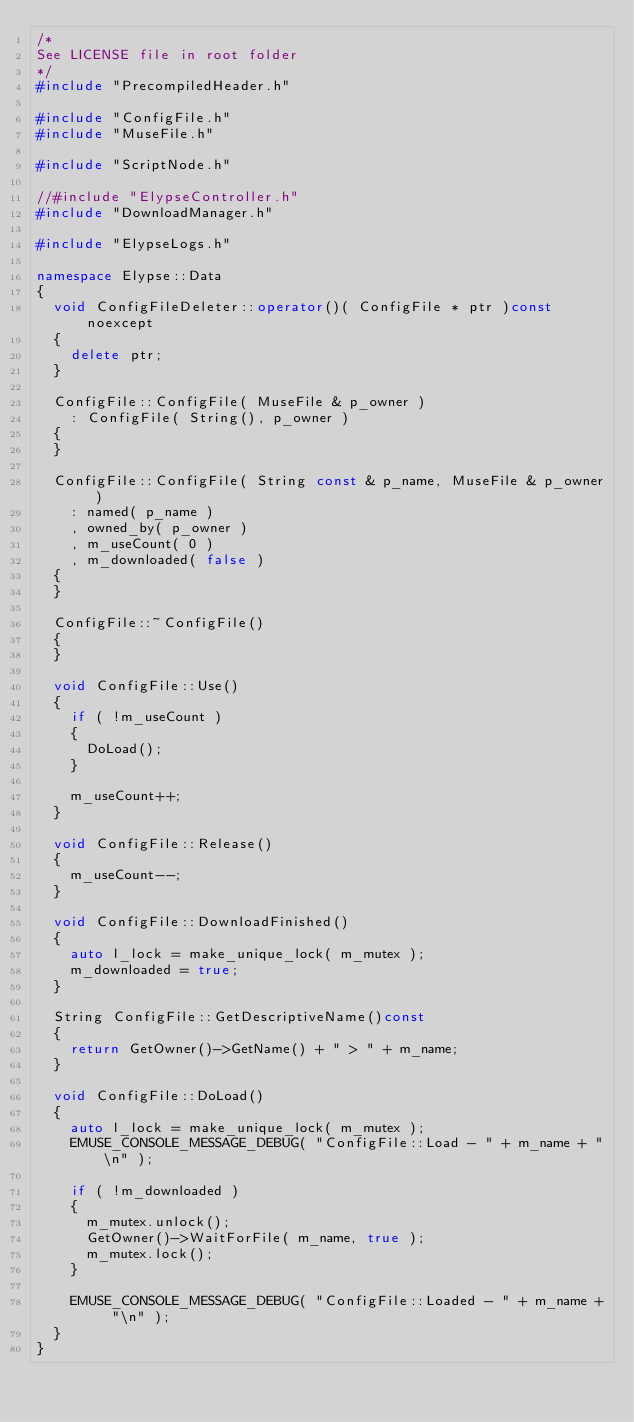<code> <loc_0><loc_0><loc_500><loc_500><_C++_>/*
See LICENSE file in root folder
*/
#include "PrecompiledHeader.h"

#include "ConfigFile.h"
#include "MuseFile.h"

#include "ScriptNode.h"

//#include "ElypseController.h"
#include "DownloadManager.h"

#include "ElypseLogs.h"

namespace Elypse::Data
{
	void ConfigFileDeleter::operator()( ConfigFile * ptr )const noexcept
	{
		delete ptr;
	}

	ConfigFile::ConfigFile( MuseFile & p_owner )
		: ConfigFile( String(), p_owner )
	{
	}

	ConfigFile::ConfigFile( String const & p_name, MuseFile & p_owner )
		: named( p_name )
		, owned_by( p_owner )
		, m_useCount( 0 )
		, m_downloaded( false )
	{
	}

	ConfigFile::~ConfigFile()
	{
	}

	void ConfigFile::Use()
	{
		if ( !m_useCount )
		{
			DoLoad();
		}

		m_useCount++;
	}

	void ConfigFile::Release()
	{
		m_useCount--;
	}

	void ConfigFile::DownloadFinished()
	{
		auto l_lock = make_unique_lock( m_mutex );
		m_downloaded = true;
	}

	String ConfigFile::GetDescriptiveName()const
	{
		return GetOwner()->GetName() + " > " + m_name;
	}

	void ConfigFile::DoLoad()
	{
		auto l_lock = make_unique_lock( m_mutex );
		EMUSE_CONSOLE_MESSAGE_DEBUG( "ConfigFile::Load - " + m_name + "\n" );

		if ( !m_downloaded )
		{
			m_mutex.unlock();
			GetOwner()->WaitForFile( m_name, true );
			m_mutex.lock();
		}

		EMUSE_CONSOLE_MESSAGE_DEBUG( "ConfigFile::Loaded - " + m_name + "\n" );
	}
}
</code> 